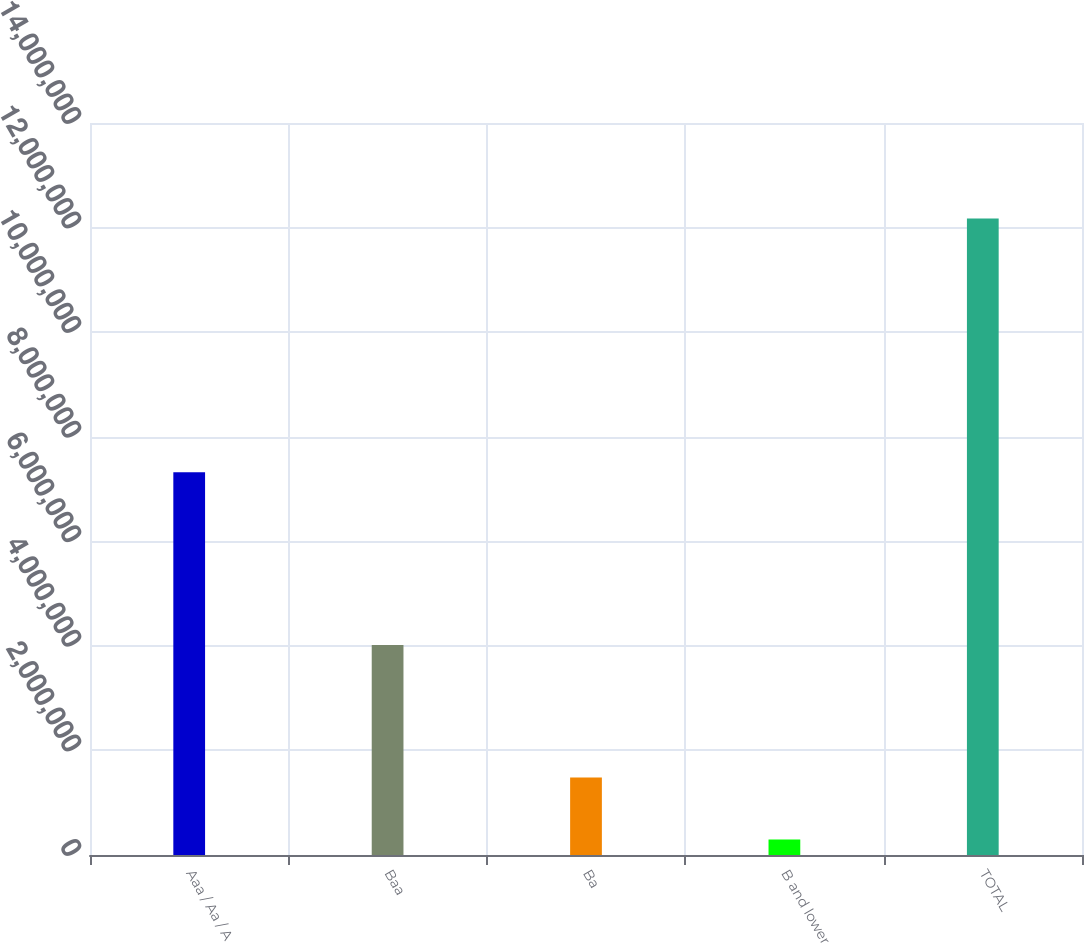Convert chart. <chart><loc_0><loc_0><loc_500><loc_500><bar_chart><fcel>Aaa / Aa / A<fcel>Baa<fcel>Ba<fcel>B and lower<fcel>TOTAL<nl><fcel>7.31901e+06<fcel>4.01461e+06<fcel>1.48291e+06<fcel>295270<fcel>1.21716e+07<nl></chart> 